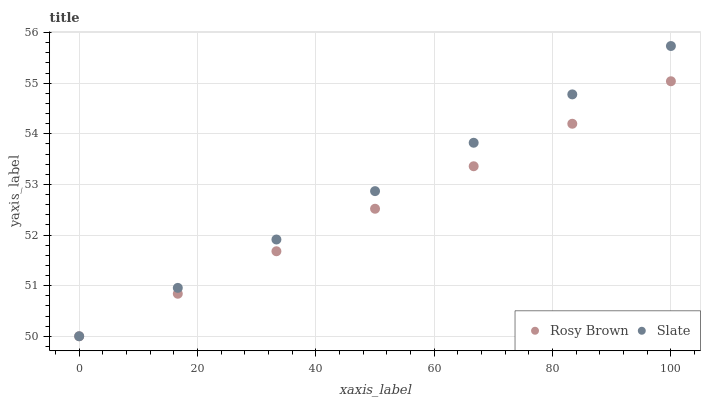Does Rosy Brown have the minimum area under the curve?
Answer yes or no. Yes. Does Slate have the maximum area under the curve?
Answer yes or no. Yes. Does Rosy Brown have the maximum area under the curve?
Answer yes or no. No. Is Slate the smoothest?
Answer yes or no. Yes. Is Rosy Brown the roughest?
Answer yes or no. Yes. Is Rosy Brown the smoothest?
Answer yes or no. No. Does Slate have the lowest value?
Answer yes or no. Yes. Does Slate have the highest value?
Answer yes or no. Yes. Does Rosy Brown have the highest value?
Answer yes or no. No. Does Rosy Brown intersect Slate?
Answer yes or no. Yes. Is Rosy Brown less than Slate?
Answer yes or no. No. Is Rosy Brown greater than Slate?
Answer yes or no. No. 